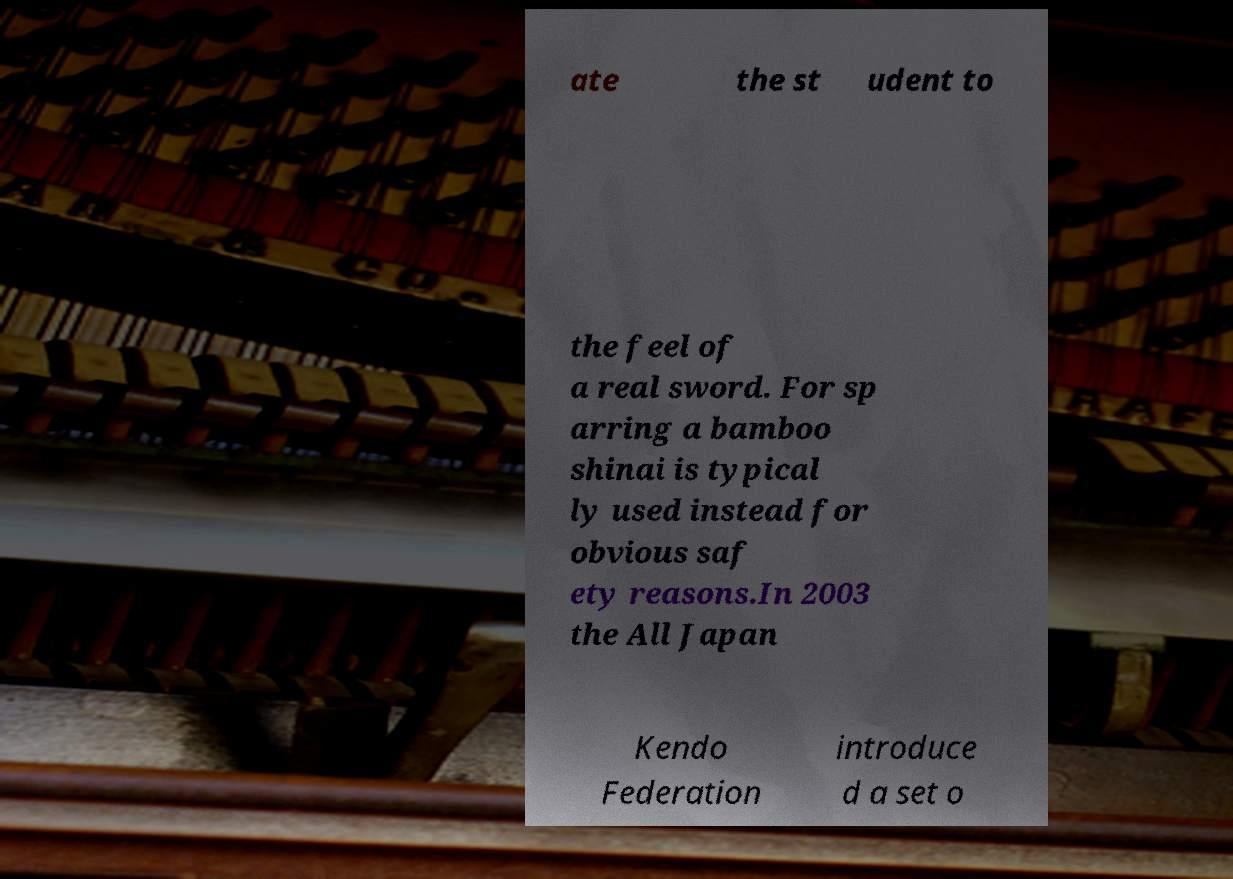Could you extract and type out the text from this image? ate the st udent to the feel of a real sword. For sp arring a bamboo shinai is typical ly used instead for obvious saf ety reasons.In 2003 the All Japan Kendo Federation introduce d a set o 